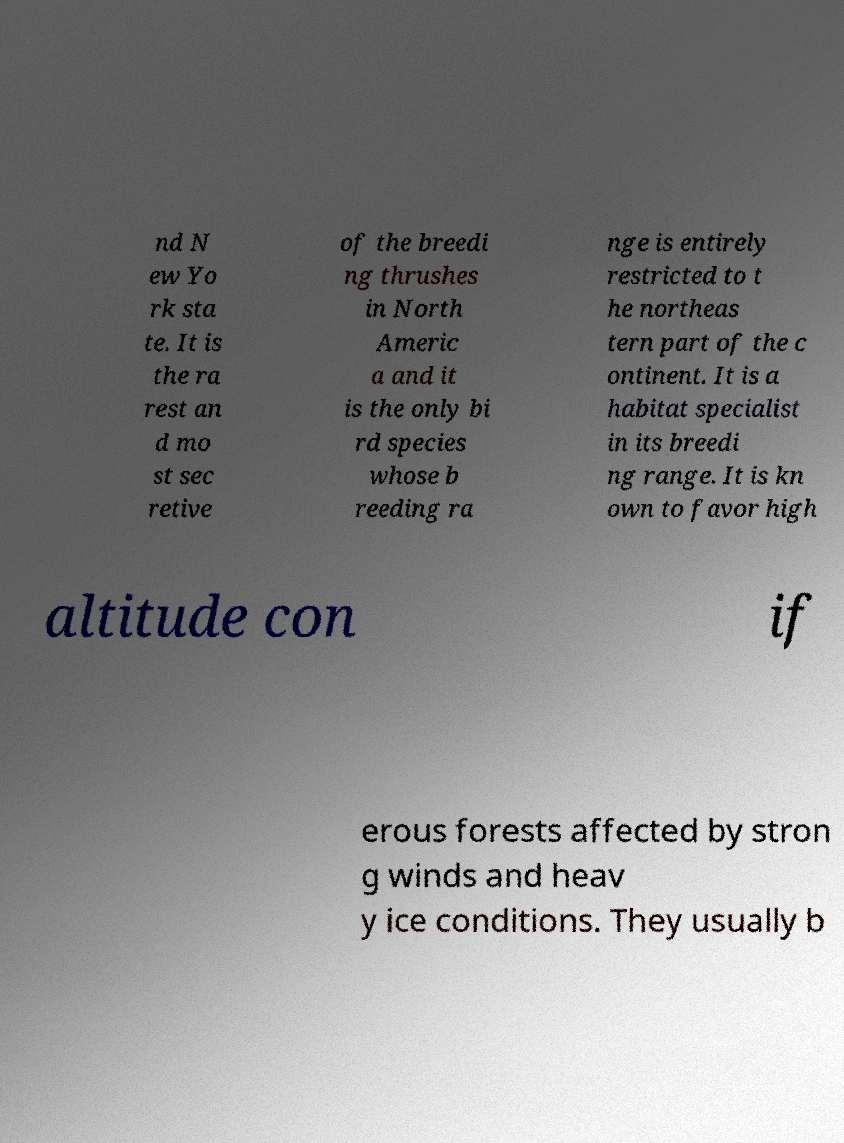Can you read and provide the text displayed in the image?This photo seems to have some interesting text. Can you extract and type it out for me? nd N ew Yo rk sta te. It is the ra rest an d mo st sec retive of the breedi ng thrushes in North Americ a and it is the only bi rd species whose b reeding ra nge is entirely restricted to t he northeas tern part of the c ontinent. It is a habitat specialist in its breedi ng range. It is kn own to favor high altitude con if erous forests affected by stron g winds and heav y ice conditions. They usually b 